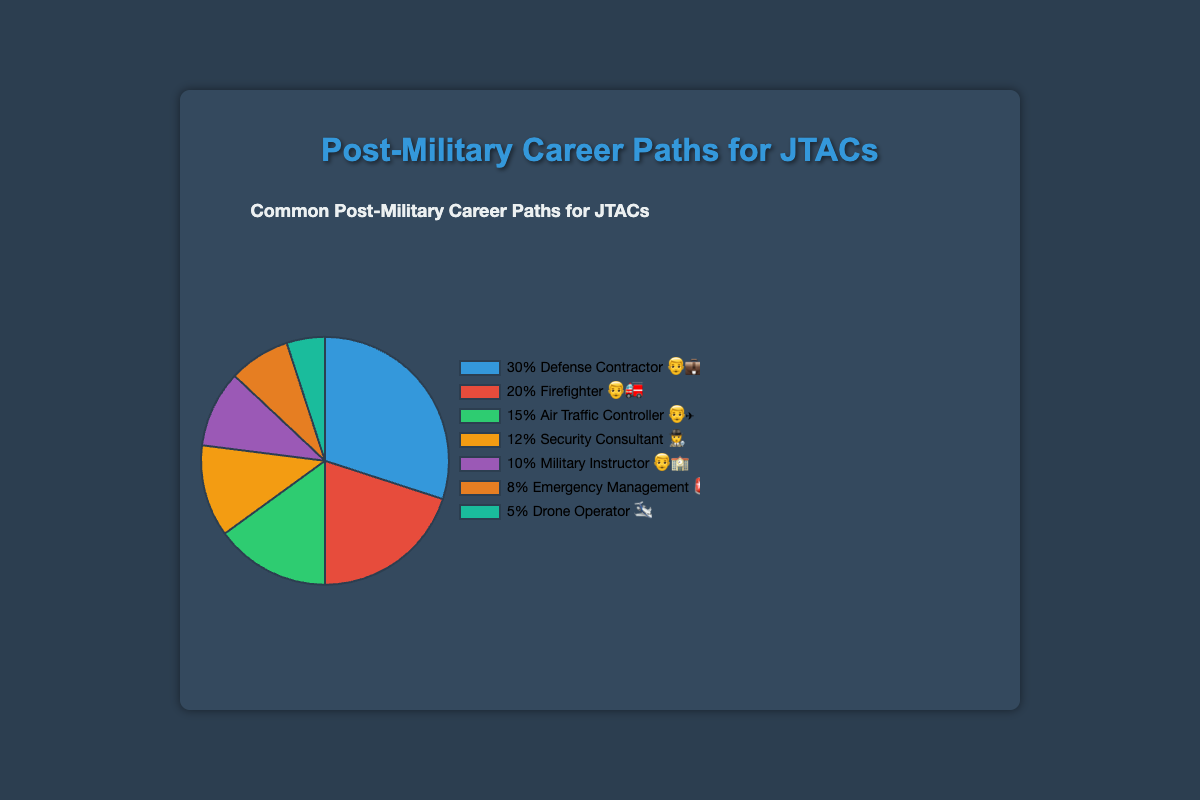What is the most common post-military career path for JTACs? The career with the highest percentage on the chart is the most common. Here, "Defense Contractor" has the highest percentage.
Answer: Defense Contractor Which profession is represented by the 👨‍🚒 emoji? Referring to the chart legend, the profession associated with the 👨‍🚒 emoji is "Firefighter".
Answer: Firefighter What are the combined percentages of the two least common career paths? The two least common career paths are "Military Instructor" (10%) and "Drone Operator" (5%). Adding these together gives 10% + 5% = 15%.
Answer: 15% How does the percentage of "Security Consultant" compare to "Air Traffic Controller"? Referring to the chart, "Air Traffic Controller" has 15% while "Security Consultant" has 12%. Therefore, "Air Traffic Controller" has a higher percentage.
Answer: Air Traffic Controller has a higher percentage Which career path is least common and how much percentage does it have? The career path with the lowest percentage is "Drone Operator" with a percentage of 5%.
Answer: Drone Operator, 5% What is the total percentage of careers related to emergency services (Firefighter and Emergency Management)? Combining the percentages of "Firefighter" (20%) and "Emergency Management" (8%), we get 20% + 8% = 28%.
Answer: 28% How does the combined percentage of "Defense Contractor" and "Military Instructor" compare to the combined percentage of "Firefighter" and "Air Traffic Controller"? Adding "Defense Contractor" (30%) and "Military Instructor" (10%) gives 40%. Adding "Firefighter" (20%) and "Air Traffic Controller" (15%) gives 35%. Thus, 40% > 35%.
Answer: More Which career path is represented by the ✈️ emoji and what is its percentage? Referring to the chart legend, the ✈️ emoji represents "Drone Operator" and the percentage is 5%.
Answer: Drone Operator, 5% 